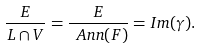<formula> <loc_0><loc_0><loc_500><loc_500>\frac { E } { L \cap V } = \frac { E } { \ A n n ( F ) } = I m ( \gamma ) .</formula> 